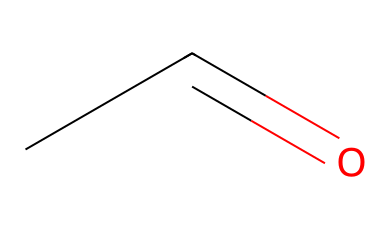What is the molecular formula of this compound? The SMILES notation "CC=O" indicates that there are two carbon atoms (C) and one oxygen atom (O), resulting in the molecular formula C2H4O.
Answer: C2H4O How many hydrogen atoms are present in acetaldehyde? The SMILES notation shows that there are four hydrogen atoms associated with the two carbons in the structure, resulting in a total of four hydrogen atoms for this compound.
Answer: 4 What functional group is present in this molecule? The presence of the carbonyl group (C=O), indicated by the "C=O" portion of the SMILES notation, denotes that this molecule has an aldehyde functional group, which is characteristic of this chemical type.
Answer: aldehyde Is acetaldehyde a saturated or unsaturated compound? The presence of a double bond between the carbon and oxygen (C=O) along with a carbon-carbon double bond (C=C) indicates that acetaldehyde is classified as an unsaturated compound.
Answer: unsaturated What type of bond exists between the carbon and oxygen in this molecule? The notation "C=O" in the SMILES representation indicates a double bond, which is a type of strong covalent bond between the carbon and oxygen atom in the molecule.
Answer: double bond What is the common use of acetaldehyde in the industry? Acetaldehyde is commonly used as an organic solvent and in the production of various chemicals, solvents, and plastics; it is particularly significant in cleaning electrical components due to its solvent properties.
Answer: solvent 